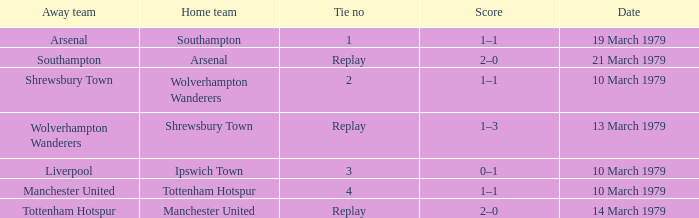Which tie number had an away team of Arsenal? 1.0. 